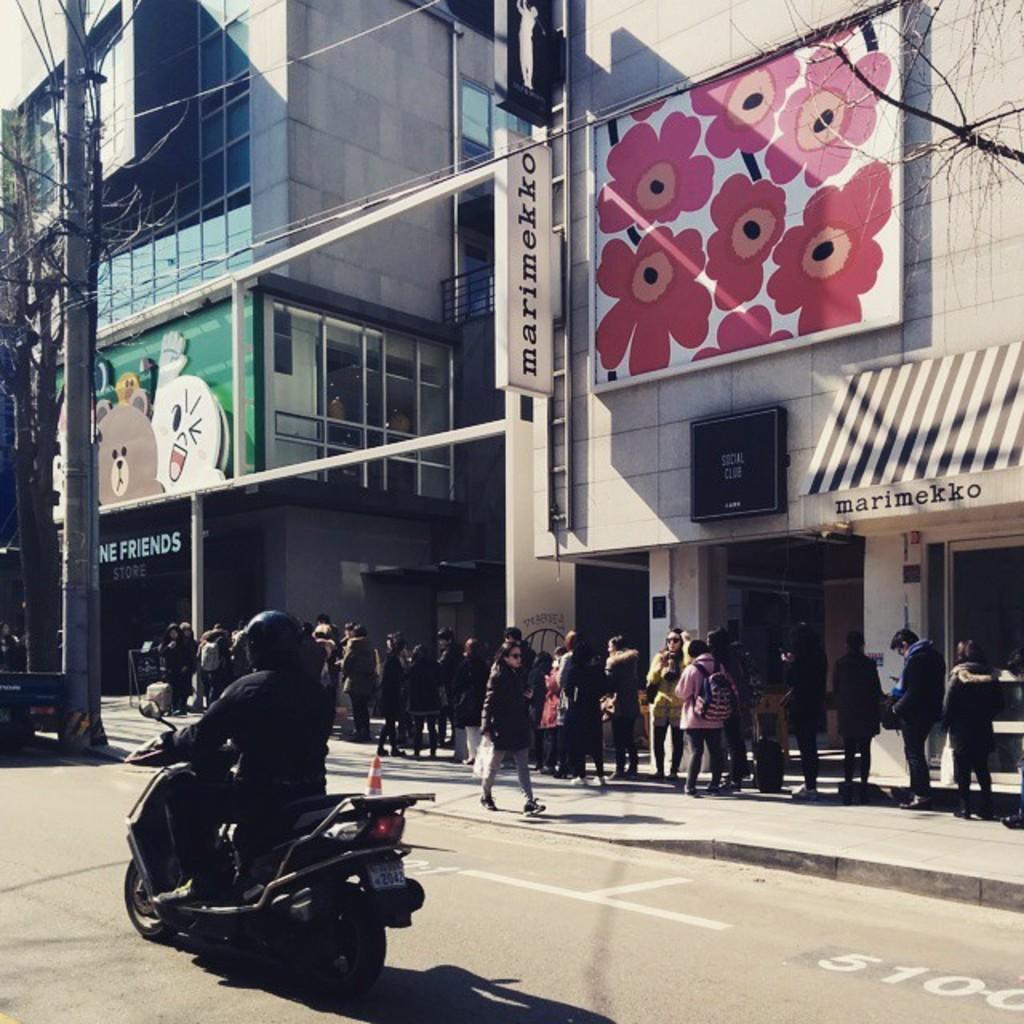Can you describe this image briefly? In the image on the road there is a person on the bike. On the footpath there are many people standing. On the left corner of the image there is an electrical pole with wires. There is a building with walls, glass windows, posters, stores with roofs and also there are name boards. And there are pillars and glass walls. 